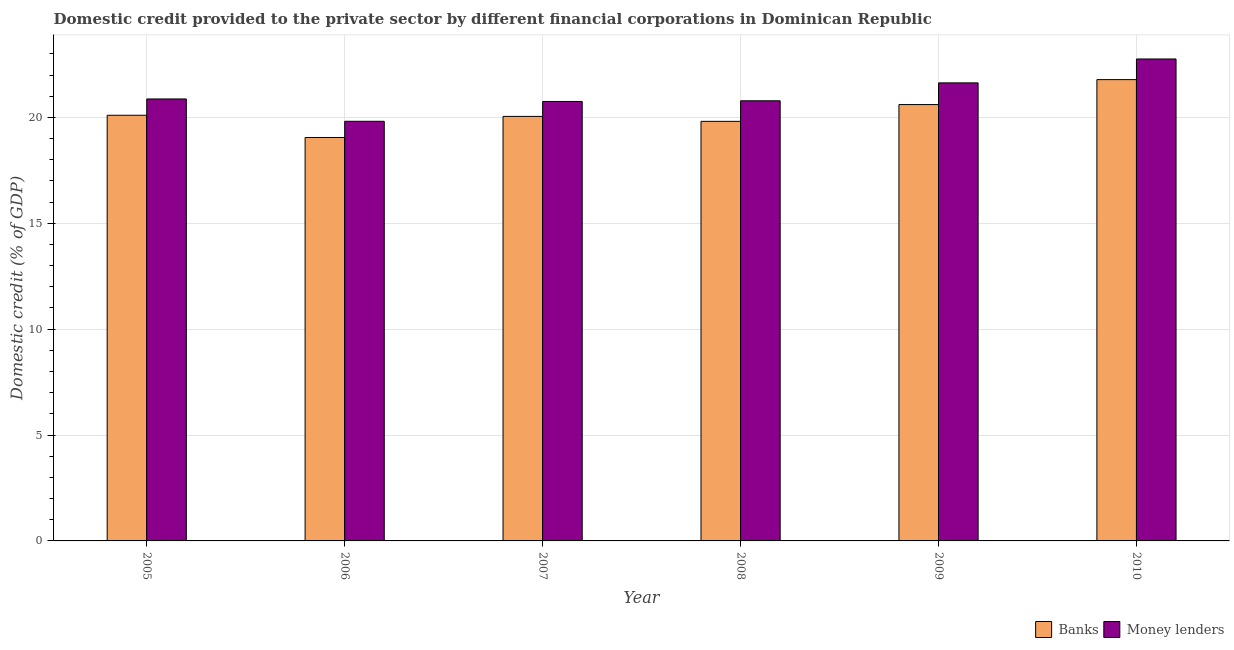How many groups of bars are there?
Ensure brevity in your answer.  6. Are the number of bars per tick equal to the number of legend labels?
Provide a short and direct response. Yes. Are the number of bars on each tick of the X-axis equal?
Ensure brevity in your answer.  Yes. How many bars are there on the 5th tick from the left?
Give a very brief answer. 2. In how many cases, is the number of bars for a given year not equal to the number of legend labels?
Make the answer very short. 0. What is the domestic credit provided by money lenders in 2006?
Provide a succinct answer. 19.82. Across all years, what is the maximum domestic credit provided by money lenders?
Your response must be concise. 22.76. Across all years, what is the minimum domestic credit provided by banks?
Your response must be concise. 19.05. In which year was the domestic credit provided by money lenders maximum?
Make the answer very short. 2010. What is the total domestic credit provided by banks in the graph?
Make the answer very short. 121.41. What is the difference between the domestic credit provided by banks in 2005 and that in 2008?
Provide a succinct answer. 0.29. What is the difference between the domestic credit provided by banks in 2005 and the domestic credit provided by money lenders in 2010?
Offer a terse response. -1.68. What is the average domestic credit provided by banks per year?
Offer a terse response. 20.23. In how many years, is the domestic credit provided by banks greater than 4 %?
Provide a short and direct response. 6. What is the ratio of the domestic credit provided by banks in 2006 to that in 2007?
Offer a very short reply. 0.95. What is the difference between the highest and the second highest domestic credit provided by money lenders?
Ensure brevity in your answer.  1.13. What is the difference between the highest and the lowest domestic credit provided by banks?
Provide a short and direct response. 2.73. What does the 1st bar from the left in 2010 represents?
Make the answer very short. Banks. What does the 1st bar from the right in 2006 represents?
Provide a succinct answer. Money lenders. How many bars are there?
Make the answer very short. 12. How many years are there in the graph?
Your answer should be compact. 6. What is the difference between two consecutive major ticks on the Y-axis?
Offer a very short reply. 5. Does the graph contain any zero values?
Your answer should be very brief. No. How many legend labels are there?
Provide a succinct answer. 2. What is the title of the graph?
Provide a short and direct response. Domestic credit provided to the private sector by different financial corporations in Dominican Republic. Does "Nonresident" appear as one of the legend labels in the graph?
Give a very brief answer. No. What is the label or title of the Y-axis?
Make the answer very short. Domestic credit (% of GDP). What is the Domestic credit (% of GDP) of Banks in 2005?
Your answer should be very brief. 20.1. What is the Domestic credit (% of GDP) in Money lenders in 2005?
Provide a short and direct response. 20.87. What is the Domestic credit (% of GDP) of Banks in 2006?
Offer a terse response. 19.05. What is the Domestic credit (% of GDP) in Money lenders in 2006?
Your answer should be very brief. 19.82. What is the Domestic credit (% of GDP) of Banks in 2007?
Offer a terse response. 20.05. What is the Domestic credit (% of GDP) of Money lenders in 2007?
Your answer should be very brief. 20.75. What is the Domestic credit (% of GDP) in Banks in 2008?
Your response must be concise. 19.81. What is the Domestic credit (% of GDP) of Money lenders in 2008?
Provide a short and direct response. 20.79. What is the Domestic credit (% of GDP) of Banks in 2009?
Your answer should be very brief. 20.61. What is the Domestic credit (% of GDP) of Money lenders in 2009?
Your answer should be very brief. 21.63. What is the Domestic credit (% of GDP) of Banks in 2010?
Ensure brevity in your answer.  21.79. What is the Domestic credit (% of GDP) in Money lenders in 2010?
Offer a very short reply. 22.76. Across all years, what is the maximum Domestic credit (% of GDP) in Banks?
Your answer should be compact. 21.79. Across all years, what is the maximum Domestic credit (% of GDP) in Money lenders?
Give a very brief answer. 22.76. Across all years, what is the minimum Domestic credit (% of GDP) in Banks?
Provide a short and direct response. 19.05. Across all years, what is the minimum Domestic credit (% of GDP) of Money lenders?
Provide a short and direct response. 19.82. What is the total Domestic credit (% of GDP) of Banks in the graph?
Keep it short and to the point. 121.41. What is the total Domestic credit (% of GDP) of Money lenders in the graph?
Provide a succinct answer. 126.62. What is the difference between the Domestic credit (% of GDP) in Banks in 2005 and that in 2006?
Provide a succinct answer. 1.05. What is the difference between the Domestic credit (% of GDP) in Money lenders in 2005 and that in 2006?
Give a very brief answer. 1.05. What is the difference between the Domestic credit (% of GDP) in Banks in 2005 and that in 2007?
Your answer should be very brief. 0.05. What is the difference between the Domestic credit (% of GDP) of Money lenders in 2005 and that in 2007?
Your response must be concise. 0.12. What is the difference between the Domestic credit (% of GDP) in Banks in 2005 and that in 2008?
Your answer should be compact. 0.29. What is the difference between the Domestic credit (% of GDP) of Money lenders in 2005 and that in 2008?
Provide a succinct answer. 0.09. What is the difference between the Domestic credit (% of GDP) of Banks in 2005 and that in 2009?
Your answer should be very brief. -0.5. What is the difference between the Domestic credit (% of GDP) of Money lenders in 2005 and that in 2009?
Your response must be concise. -0.76. What is the difference between the Domestic credit (% of GDP) in Banks in 2005 and that in 2010?
Give a very brief answer. -1.68. What is the difference between the Domestic credit (% of GDP) in Money lenders in 2005 and that in 2010?
Keep it short and to the point. -1.89. What is the difference between the Domestic credit (% of GDP) of Banks in 2006 and that in 2007?
Your answer should be very brief. -1. What is the difference between the Domestic credit (% of GDP) in Money lenders in 2006 and that in 2007?
Your answer should be compact. -0.94. What is the difference between the Domestic credit (% of GDP) of Banks in 2006 and that in 2008?
Keep it short and to the point. -0.76. What is the difference between the Domestic credit (% of GDP) in Money lenders in 2006 and that in 2008?
Offer a very short reply. -0.97. What is the difference between the Domestic credit (% of GDP) in Banks in 2006 and that in 2009?
Make the answer very short. -1.55. What is the difference between the Domestic credit (% of GDP) of Money lenders in 2006 and that in 2009?
Offer a very short reply. -1.81. What is the difference between the Domestic credit (% of GDP) of Banks in 2006 and that in 2010?
Provide a short and direct response. -2.73. What is the difference between the Domestic credit (% of GDP) in Money lenders in 2006 and that in 2010?
Your response must be concise. -2.94. What is the difference between the Domestic credit (% of GDP) of Banks in 2007 and that in 2008?
Offer a very short reply. 0.23. What is the difference between the Domestic credit (% of GDP) in Money lenders in 2007 and that in 2008?
Your response must be concise. -0.03. What is the difference between the Domestic credit (% of GDP) in Banks in 2007 and that in 2009?
Offer a terse response. -0.56. What is the difference between the Domestic credit (% of GDP) of Money lenders in 2007 and that in 2009?
Your answer should be very brief. -0.88. What is the difference between the Domestic credit (% of GDP) in Banks in 2007 and that in 2010?
Give a very brief answer. -1.74. What is the difference between the Domestic credit (% of GDP) in Money lenders in 2007 and that in 2010?
Make the answer very short. -2.01. What is the difference between the Domestic credit (% of GDP) in Banks in 2008 and that in 2009?
Ensure brevity in your answer.  -0.79. What is the difference between the Domestic credit (% of GDP) in Money lenders in 2008 and that in 2009?
Offer a terse response. -0.85. What is the difference between the Domestic credit (% of GDP) in Banks in 2008 and that in 2010?
Your answer should be very brief. -1.97. What is the difference between the Domestic credit (% of GDP) in Money lenders in 2008 and that in 2010?
Give a very brief answer. -1.97. What is the difference between the Domestic credit (% of GDP) in Banks in 2009 and that in 2010?
Keep it short and to the point. -1.18. What is the difference between the Domestic credit (% of GDP) in Money lenders in 2009 and that in 2010?
Provide a short and direct response. -1.13. What is the difference between the Domestic credit (% of GDP) in Banks in 2005 and the Domestic credit (% of GDP) in Money lenders in 2006?
Keep it short and to the point. 0.28. What is the difference between the Domestic credit (% of GDP) in Banks in 2005 and the Domestic credit (% of GDP) in Money lenders in 2007?
Your response must be concise. -0.65. What is the difference between the Domestic credit (% of GDP) in Banks in 2005 and the Domestic credit (% of GDP) in Money lenders in 2008?
Provide a succinct answer. -0.68. What is the difference between the Domestic credit (% of GDP) in Banks in 2005 and the Domestic credit (% of GDP) in Money lenders in 2009?
Make the answer very short. -1.53. What is the difference between the Domestic credit (% of GDP) in Banks in 2005 and the Domestic credit (% of GDP) in Money lenders in 2010?
Your answer should be compact. -2.66. What is the difference between the Domestic credit (% of GDP) in Banks in 2006 and the Domestic credit (% of GDP) in Money lenders in 2007?
Provide a short and direct response. -1.7. What is the difference between the Domestic credit (% of GDP) in Banks in 2006 and the Domestic credit (% of GDP) in Money lenders in 2008?
Provide a short and direct response. -1.73. What is the difference between the Domestic credit (% of GDP) in Banks in 2006 and the Domestic credit (% of GDP) in Money lenders in 2009?
Give a very brief answer. -2.58. What is the difference between the Domestic credit (% of GDP) in Banks in 2006 and the Domestic credit (% of GDP) in Money lenders in 2010?
Provide a succinct answer. -3.71. What is the difference between the Domestic credit (% of GDP) of Banks in 2007 and the Domestic credit (% of GDP) of Money lenders in 2008?
Provide a short and direct response. -0.74. What is the difference between the Domestic credit (% of GDP) of Banks in 2007 and the Domestic credit (% of GDP) of Money lenders in 2009?
Provide a short and direct response. -1.58. What is the difference between the Domestic credit (% of GDP) of Banks in 2007 and the Domestic credit (% of GDP) of Money lenders in 2010?
Give a very brief answer. -2.71. What is the difference between the Domestic credit (% of GDP) of Banks in 2008 and the Domestic credit (% of GDP) of Money lenders in 2009?
Offer a very short reply. -1.82. What is the difference between the Domestic credit (% of GDP) of Banks in 2008 and the Domestic credit (% of GDP) of Money lenders in 2010?
Your answer should be very brief. -2.95. What is the difference between the Domestic credit (% of GDP) of Banks in 2009 and the Domestic credit (% of GDP) of Money lenders in 2010?
Provide a short and direct response. -2.15. What is the average Domestic credit (% of GDP) of Banks per year?
Give a very brief answer. 20.23. What is the average Domestic credit (% of GDP) in Money lenders per year?
Your answer should be very brief. 21.1. In the year 2005, what is the difference between the Domestic credit (% of GDP) in Banks and Domestic credit (% of GDP) in Money lenders?
Your response must be concise. -0.77. In the year 2006, what is the difference between the Domestic credit (% of GDP) in Banks and Domestic credit (% of GDP) in Money lenders?
Offer a very short reply. -0.77. In the year 2007, what is the difference between the Domestic credit (% of GDP) in Banks and Domestic credit (% of GDP) in Money lenders?
Ensure brevity in your answer.  -0.7. In the year 2008, what is the difference between the Domestic credit (% of GDP) in Banks and Domestic credit (% of GDP) in Money lenders?
Provide a succinct answer. -0.97. In the year 2009, what is the difference between the Domestic credit (% of GDP) of Banks and Domestic credit (% of GDP) of Money lenders?
Offer a very short reply. -1.02. In the year 2010, what is the difference between the Domestic credit (% of GDP) in Banks and Domestic credit (% of GDP) in Money lenders?
Provide a succinct answer. -0.97. What is the ratio of the Domestic credit (% of GDP) of Banks in 2005 to that in 2006?
Your response must be concise. 1.06. What is the ratio of the Domestic credit (% of GDP) in Money lenders in 2005 to that in 2006?
Provide a succinct answer. 1.05. What is the ratio of the Domestic credit (% of GDP) in Banks in 2005 to that in 2007?
Offer a very short reply. 1. What is the ratio of the Domestic credit (% of GDP) in Money lenders in 2005 to that in 2007?
Ensure brevity in your answer.  1.01. What is the ratio of the Domestic credit (% of GDP) of Banks in 2005 to that in 2008?
Offer a terse response. 1.01. What is the ratio of the Domestic credit (% of GDP) of Money lenders in 2005 to that in 2008?
Provide a short and direct response. 1. What is the ratio of the Domestic credit (% of GDP) of Banks in 2005 to that in 2009?
Your answer should be very brief. 0.98. What is the ratio of the Domestic credit (% of GDP) in Money lenders in 2005 to that in 2009?
Make the answer very short. 0.96. What is the ratio of the Domestic credit (% of GDP) of Banks in 2005 to that in 2010?
Provide a short and direct response. 0.92. What is the ratio of the Domestic credit (% of GDP) in Money lenders in 2005 to that in 2010?
Make the answer very short. 0.92. What is the ratio of the Domestic credit (% of GDP) in Banks in 2006 to that in 2007?
Keep it short and to the point. 0.95. What is the ratio of the Domestic credit (% of GDP) of Money lenders in 2006 to that in 2007?
Ensure brevity in your answer.  0.95. What is the ratio of the Domestic credit (% of GDP) in Banks in 2006 to that in 2008?
Offer a terse response. 0.96. What is the ratio of the Domestic credit (% of GDP) of Money lenders in 2006 to that in 2008?
Offer a terse response. 0.95. What is the ratio of the Domestic credit (% of GDP) of Banks in 2006 to that in 2009?
Provide a short and direct response. 0.92. What is the ratio of the Domestic credit (% of GDP) in Money lenders in 2006 to that in 2009?
Offer a terse response. 0.92. What is the ratio of the Domestic credit (% of GDP) of Banks in 2006 to that in 2010?
Your answer should be very brief. 0.87. What is the ratio of the Domestic credit (% of GDP) of Money lenders in 2006 to that in 2010?
Your response must be concise. 0.87. What is the ratio of the Domestic credit (% of GDP) of Banks in 2007 to that in 2008?
Offer a very short reply. 1.01. What is the ratio of the Domestic credit (% of GDP) in Banks in 2007 to that in 2009?
Ensure brevity in your answer.  0.97. What is the ratio of the Domestic credit (% of GDP) of Money lenders in 2007 to that in 2009?
Your answer should be very brief. 0.96. What is the ratio of the Domestic credit (% of GDP) in Banks in 2007 to that in 2010?
Provide a succinct answer. 0.92. What is the ratio of the Domestic credit (% of GDP) of Money lenders in 2007 to that in 2010?
Provide a succinct answer. 0.91. What is the ratio of the Domestic credit (% of GDP) in Banks in 2008 to that in 2009?
Your answer should be very brief. 0.96. What is the ratio of the Domestic credit (% of GDP) in Money lenders in 2008 to that in 2009?
Your answer should be compact. 0.96. What is the ratio of the Domestic credit (% of GDP) of Banks in 2008 to that in 2010?
Offer a very short reply. 0.91. What is the ratio of the Domestic credit (% of GDP) of Money lenders in 2008 to that in 2010?
Offer a terse response. 0.91. What is the ratio of the Domestic credit (% of GDP) in Banks in 2009 to that in 2010?
Offer a very short reply. 0.95. What is the ratio of the Domestic credit (% of GDP) in Money lenders in 2009 to that in 2010?
Offer a very short reply. 0.95. What is the difference between the highest and the second highest Domestic credit (% of GDP) in Banks?
Your answer should be compact. 1.18. What is the difference between the highest and the second highest Domestic credit (% of GDP) of Money lenders?
Your answer should be compact. 1.13. What is the difference between the highest and the lowest Domestic credit (% of GDP) of Banks?
Make the answer very short. 2.73. What is the difference between the highest and the lowest Domestic credit (% of GDP) of Money lenders?
Provide a short and direct response. 2.94. 